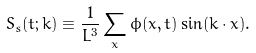Convert formula to latex. <formula><loc_0><loc_0><loc_500><loc_500>S _ { s } ( t ; { k } ) \equiv \frac { 1 } { L ^ { 3 } } \sum _ { x } \phi ( { x } , t ) \sin ( { k } \cdot { x } ) .</formula> 